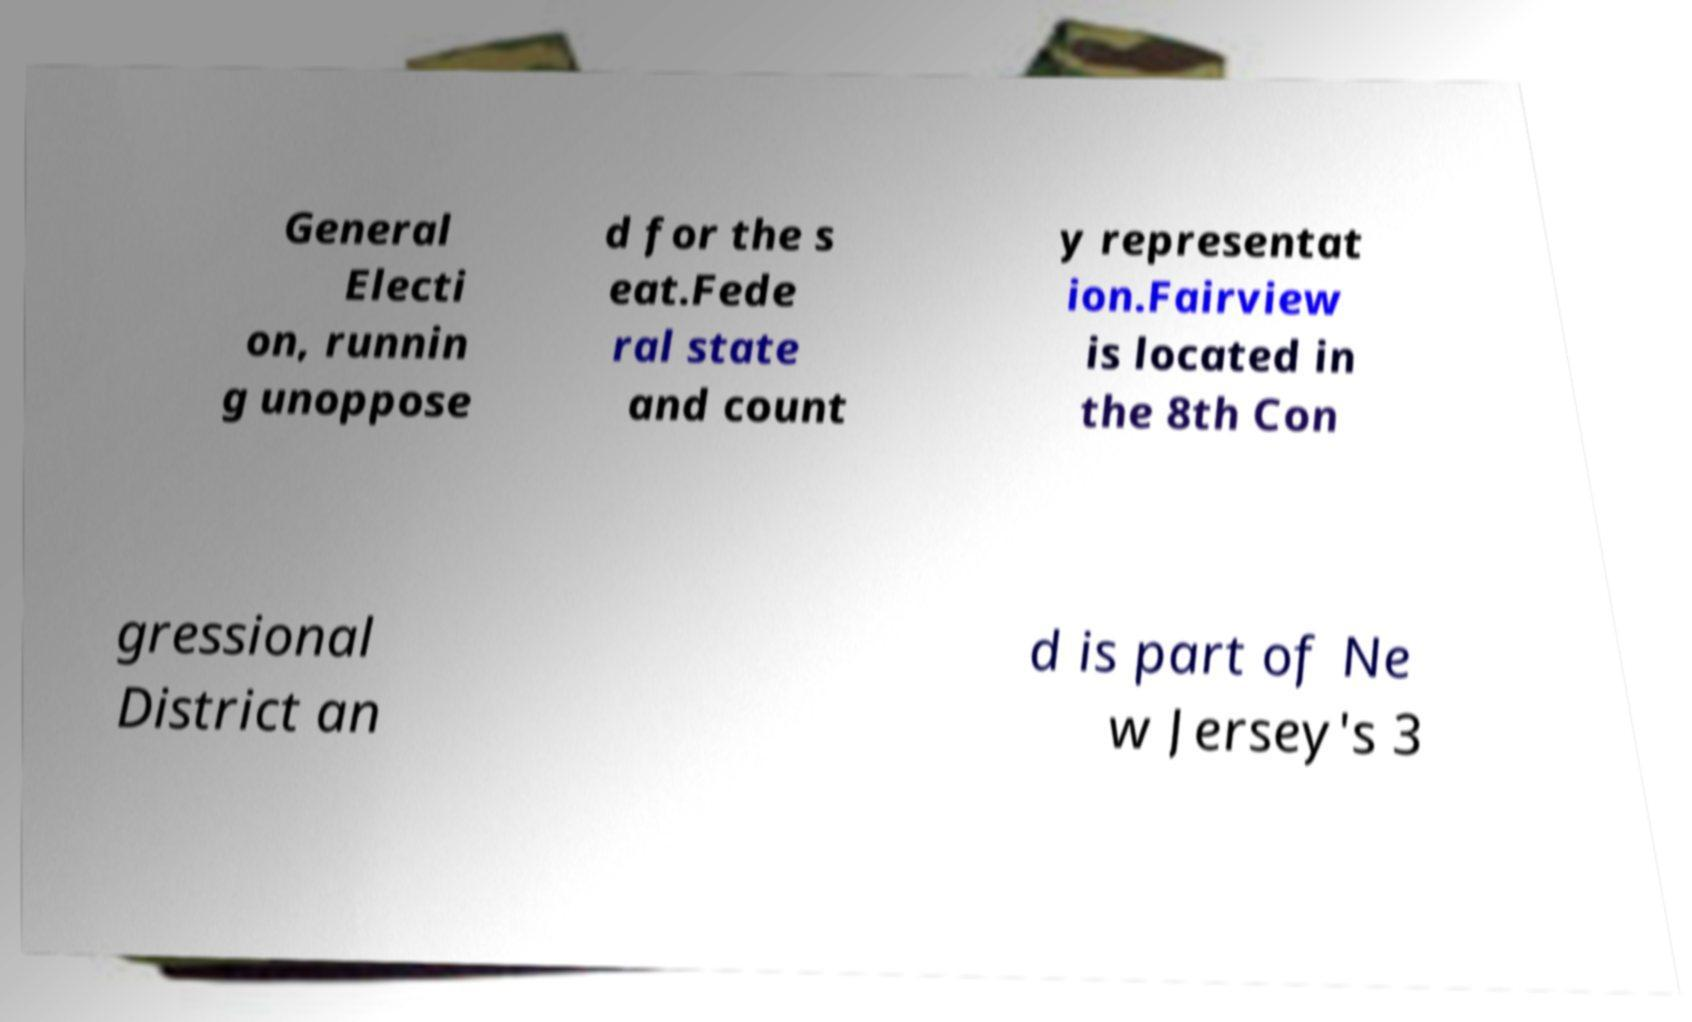Could you extract and type out the text from this image? General Electi on, runnin g unoppose d for the s eat.Fede ral state and count y representat ion.Fairview is located in the 8th Con gressional District an d is part of Ne w Jersey's 3 